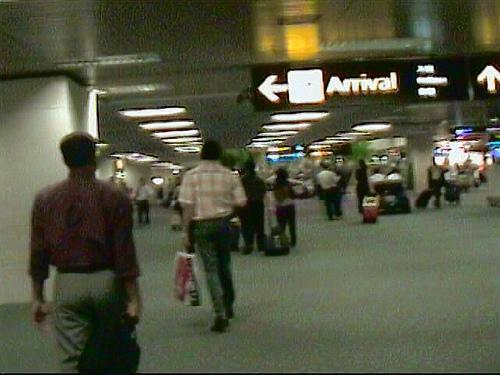How many people are there?
Give a very brief answer. 2. 